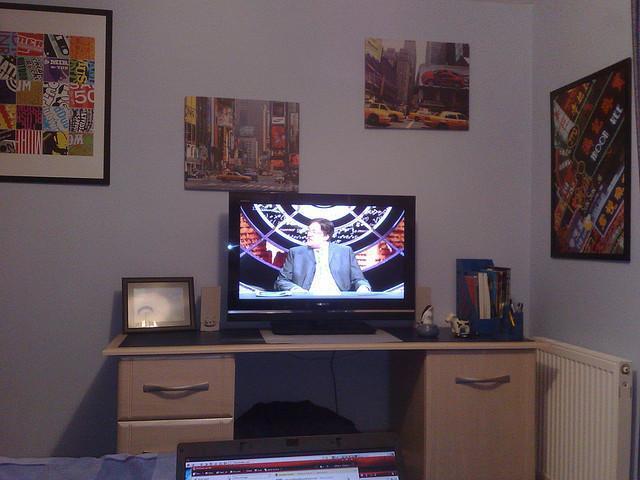How many people can be seen on the screen?
Give a very brief answer. 1. How many pictures on the wall?
Give a very brief answer. 4. How many computer monitors are there?
Give a very brief answer. 1. How many monitors are on the desk?
Give a very brief answer. 1. How many zebras are here?
Give a very brief answer. 0. 